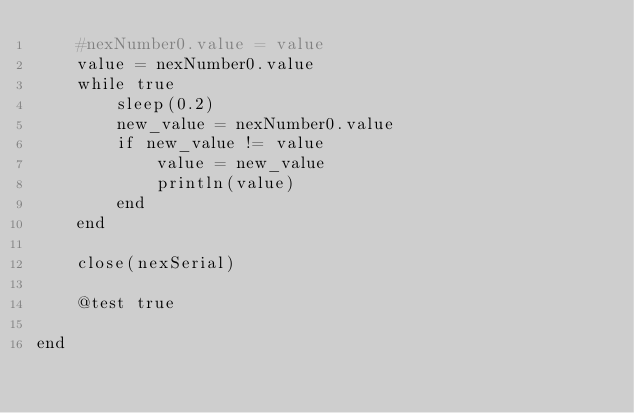Convert code to text. <code><loc_0><loc_0><loc_500><loc_500><_Julia_>    #nexNumber0.value = value
    value = nexNumber0.value
    while true
        sleep(0.2)
        new_value = nexNumber0.value
        if new_value != value
            value = new_value
            println(value)
        end
    end

    close(nexSerial)

    @test true

end
</code> 